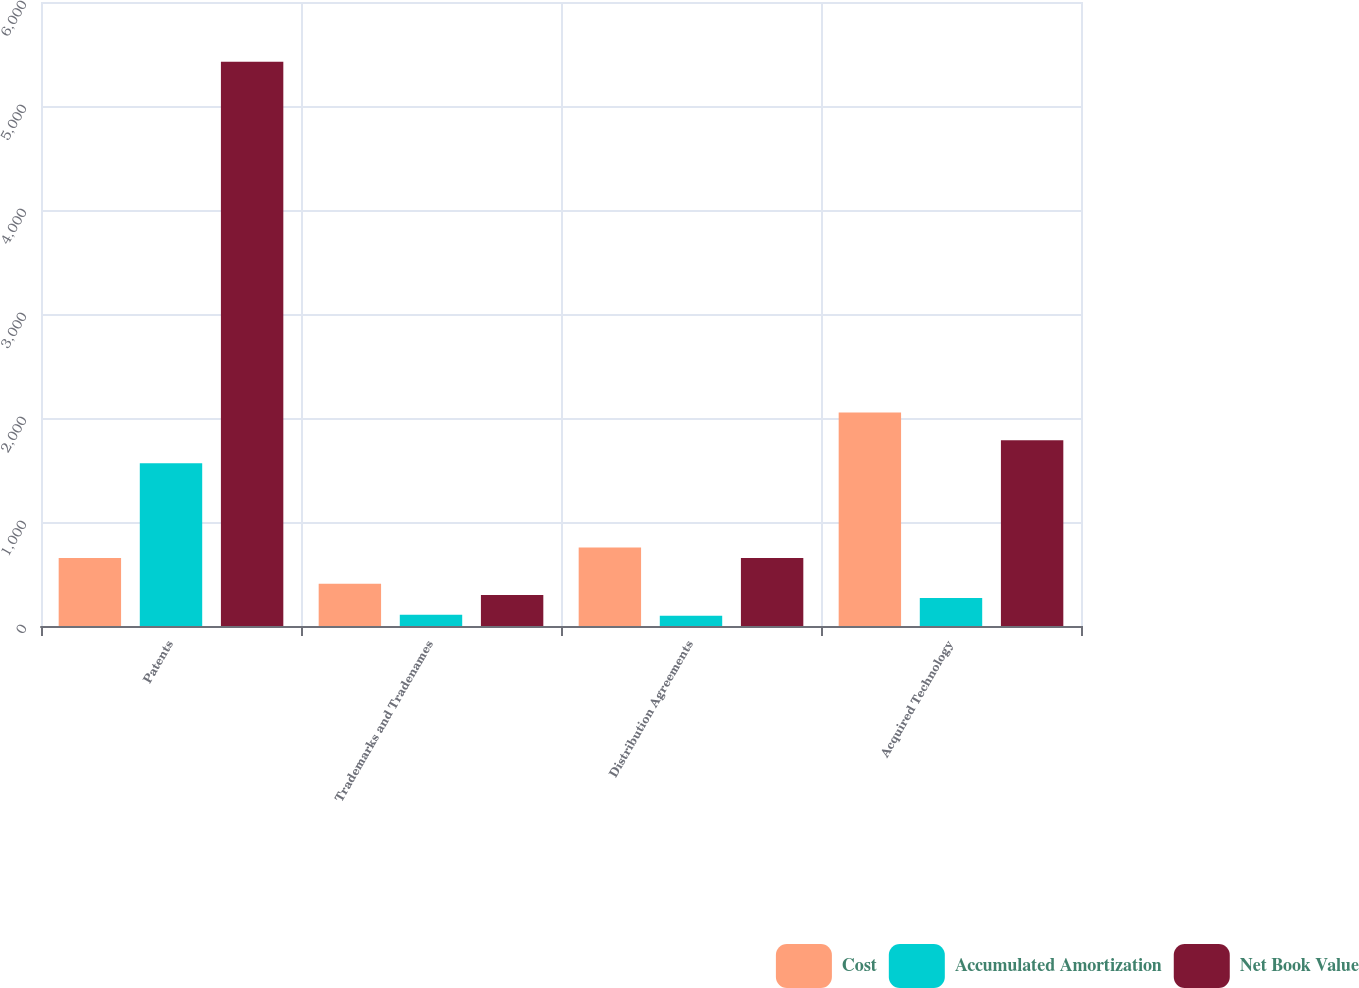<chart> <loc_0><loc_0><loc_500><loc_500><stacked_bar_chart><ecel><fcel>Patents<fcel>Trademarks and Tradenames<fcel>Distribution Agreements<fcel>Acquired Technology<nl><fcel>Cost<fcel>655<fcel>407<fcel>754<fcel>2054<nl><fcel>Accumulated Amortization<fcel>1564<fcel>109<fcel>99<fcel>269<nl><fcel>Net Book Value<fcel>5426<fcel>298<fcel>655<fcel>1785<nl></chart> 